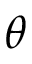<formula> <loc_0><loc_0><loc_500><loc_500>\theta</formula> 